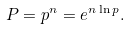Convert formula to latex. <formula><loc_0><loc_0><loc_500><loc_500>P = p ^ { n } = e ^ { n \ln { p } } .</formula> 